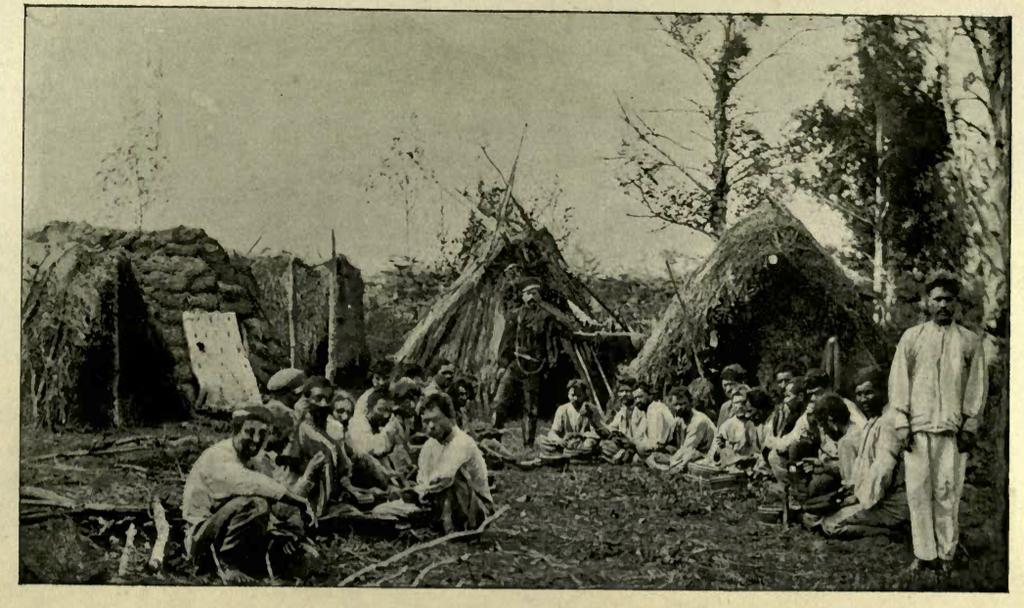What are the people in the image doing? There are people standing and seated on the ground in the image. What can be seen in the background of the image? There are huts and trees visible in the background of the image. What objects are on the ground in the image? There are sticks on the ground in the image. What type of beast can be seen roaming around in the image? There is no beast present in the image. What is the cannon used for in the image? There is no cannon present in the image. 